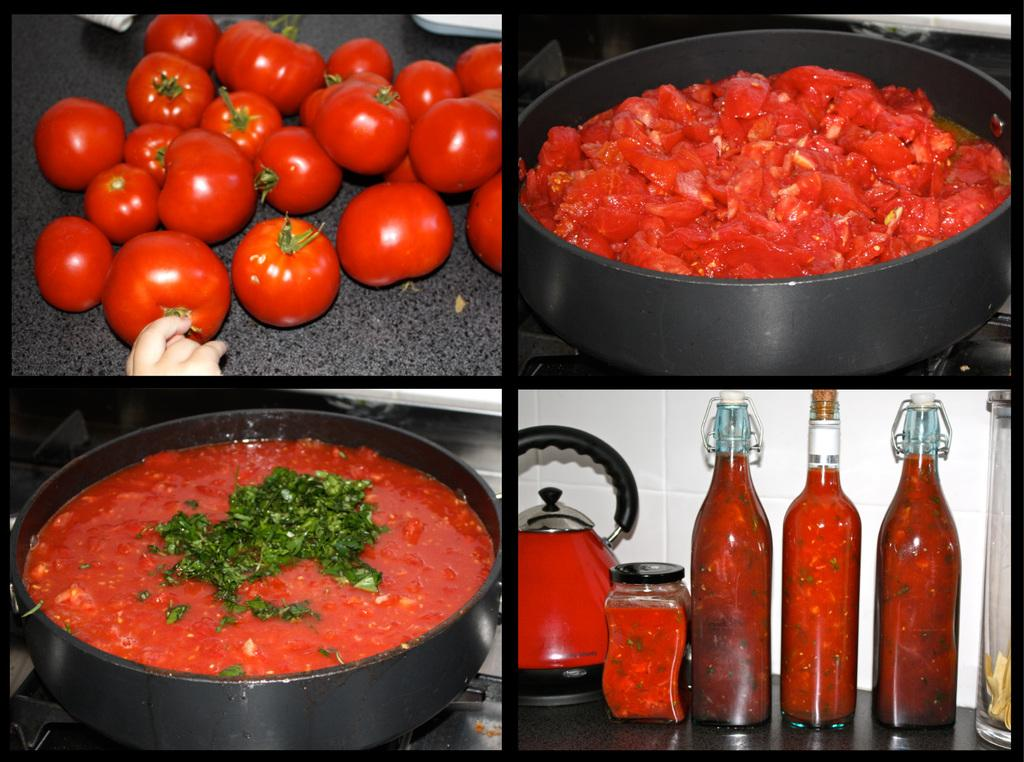What type of artwork is the image? The image is a collage. What type of food is featured in the image? There are tomatoes in the image. What is the recipe in the image contained in? The recipe is in a bowl in the image. What is another kitchen item present in the image? There is a teapot in the image. What type of container is present in the image? There is a jar in the image. What else can be seen on the table in the image? There are bottles on the table in the image. What is the state of the tomatoes in one of the containers in the image? There is a container with smashed tomatoes in the image. What type of coil is used in the recipe in the image? There is no mention of a coil in the image or the provided facts. 